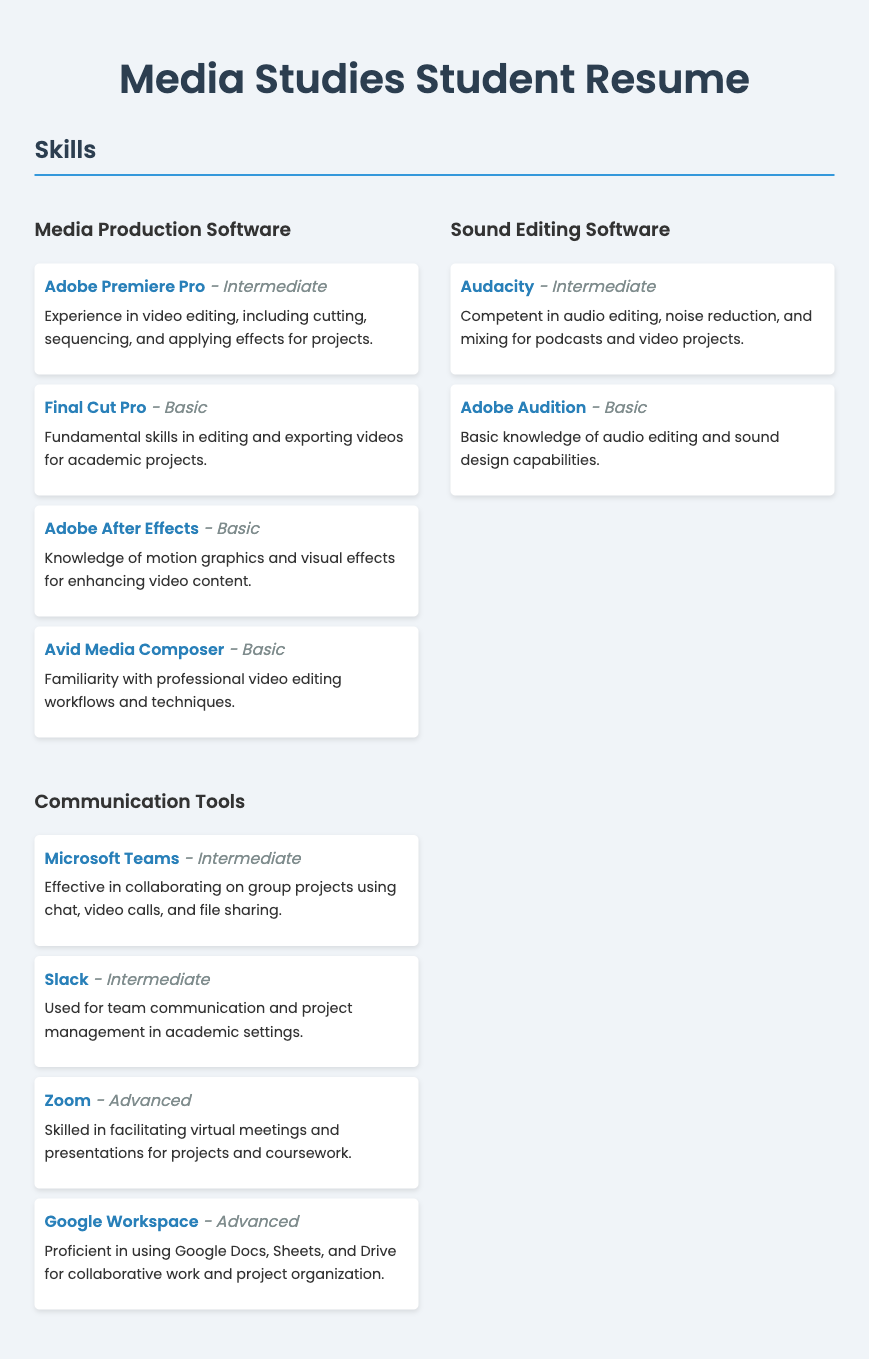What is the highest proficiency level listed for sound editing software? The highest proficiency level listed for sound editing software is Intermediate as indicated for Audacity.
Answer: Intermediate Which communication tool is mentioned with Advanced proficiency? The communication tools with Advanced proficiency mentioned are Zoom and Google Workspace.
Answer: Zoom, Google Workspace How many software tools are categorized under Media Production Software? There are four software tools listed under Media Production Software in the skills section.
Answer: 4 What is the proficiency level of Adobe Audition? Adobe Audition is listed with Basic proficiency in the skills section.
Answer: Basic Which video editing software has the highest proficiency level according to the resume? Adobe Premiere Pro is noted as the highest proficiency level listed at Intermediate.
Answer: Adobe Premiere Pro How many communication tools are listed in the skills section? There are four communication tools detailed in the skills section of the resume.
Answer: 4 What type of projects is Audacity associated with in the document? Audacity is associated with podcasts and video projects in the skills description.
Answer: podcasts and video projects Name a software tool that is listed as Basic proficiency under Media Production Software. Adobe After Effects is mentioned with Basic proficiency under Media Production Software.
Answer: Adobe After Effects 